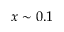<formula> <loc_0><loc_0><loc_500><loc_500>x \sim 0 . 1</formula> 